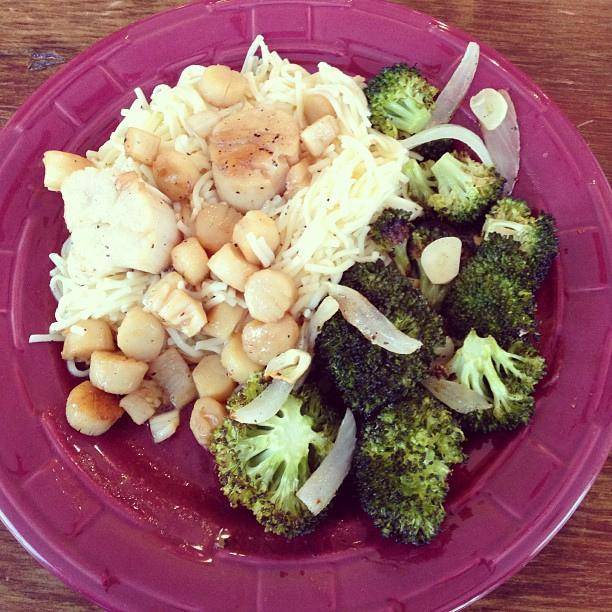What type of seafood is being served? Please explain your reasoning. scallops. The seafood is small round pieces that don't have a tail. 